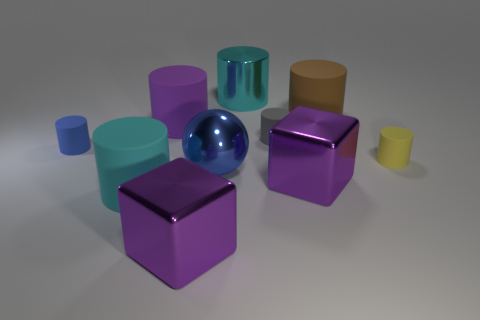Does the purple metallic object that is right of the gray cylinder have the same size as the big brown cylinder?
Offer a terse response. Yes. Is the number of small red spheres greater than the number of blue spheres?
Your answer should be compact. No. What number of big things are either purple objects or green things?
Your answer should be very brief. 3. How many other things are the same color as the large metal sphere?
Keep it short and to the point. 1. How many tiny blue things have the same material as the tiny yellow cylinder?
Your answer should be very brief. 1. There is a small cylinder to the left of the large cyan metal thing; is it the same color as the ball?
Make the answer very short. Yes. What number of red objects are either large blocks or big metal cylinders?
Your answer should be compact. 0. Is the material of the tiny object in front of the tiny blue object the same as the brown cylinder?
Your answer should be very brief. Yes. What number of objects are large green metal cylinders or gray cylinders behind the tiny yellow rubber thing?
Keep it short and to the point. 1. There is a big purple metallic cube that is left of the large metal object behind the yellow rubber thing; what number of large purple blocks are behind it?
Offer a terse response. 1. 